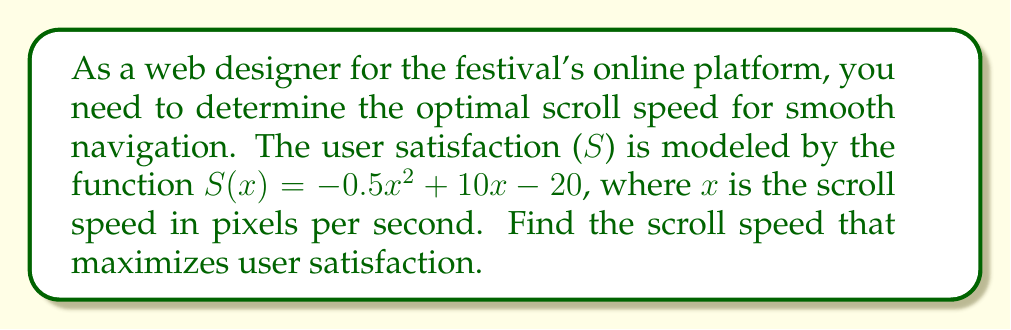What is the answer to this math problem? To find the optimal scroll speed that maximizes user satisfaction, we need to find the maximum point of the function $S(x) = -0.5x^2 + 10x - 20$. This can be done by finding the derivative of S(x), setting it equal to zero, and solving for x.

Step 1: Find the derivative of S(x)
$$\frac{d}{dx}S(x) = \frac{d}{dx}(-0.5x^2 + 10x - 20)$$
$$S'(x) = -x + 10$$

Step 2: Set the derivative equal to zero and solve for x
$$S'(x) = 0$$
$$-x + 10 = 0$$
$$x = 10$$

Step 3: Verify that this is a maximum point
The second derivative of S(x) is:
$$S''(x) = -1$$
Since $S''(x)$ is negative, the critical point x = 10 is indeed a maximum.

Therefore, the optimal scroll speed that maximizes user satisfaction is 10 pixels per second.
Answer: 10 pixels per second 